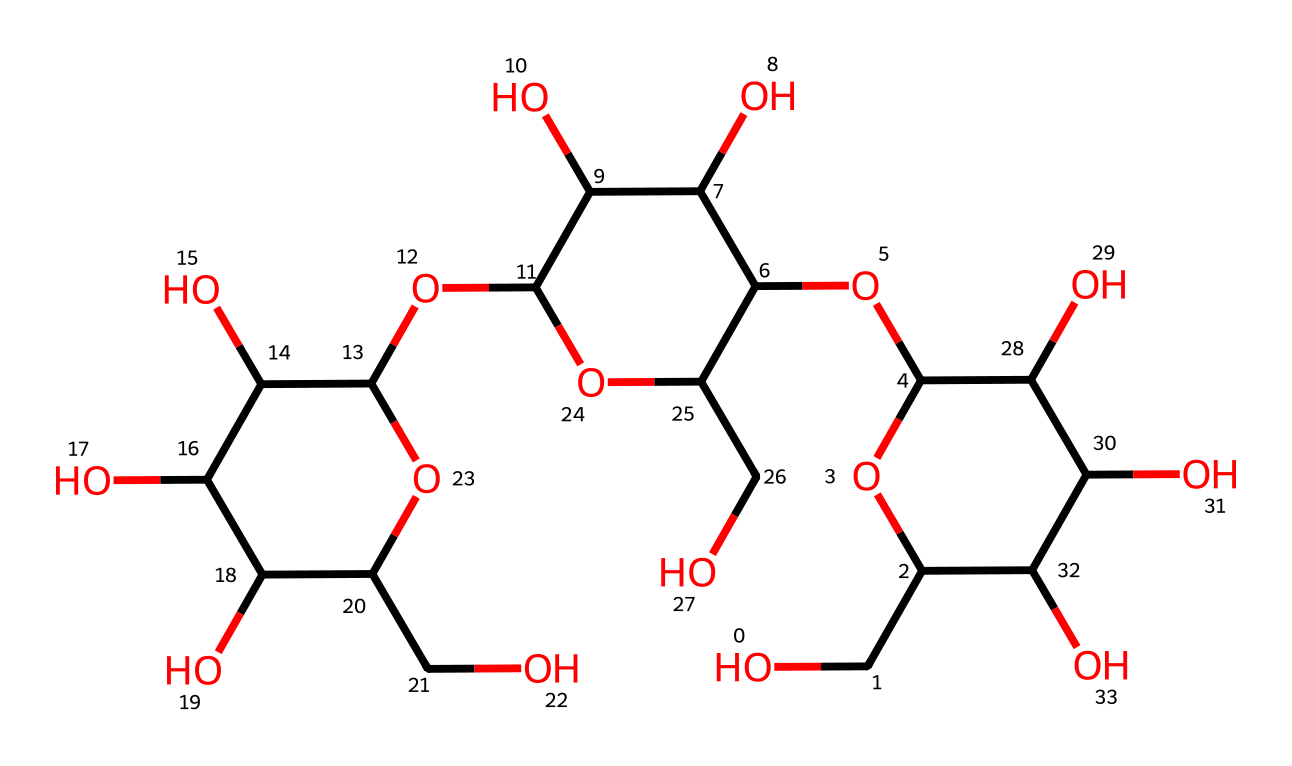What is the molecular formula of this rayon fiber? To determine the molecular formula, we need to count the number of carbon (C), hydrogen (H), and oxygen (O) atoms present in the SMILES representation. By analyzing the structure, we can identify 18 carbon atoms, 34 hydrogen atoms, and 10 oxygen atoms. Therefore, the molecular formula is C18H34O10.
Answer: C18H34O10 How many rings are present in this chemical structure? The SMILES representation illustrates a complex structure with multiple cyclic components. By comparing the depiction in the SMILES notation, we can observe that there are three distinct ring structures within the chemical, indicating three rings are present.
Answer: 3 What functional groups are evident in the structure? By examining the structure, we can identify hydroxyl (OH) groups attached to multiple carbon atoms throughout the molecule. These hydroxy functional groups are responsible for the chemical's interactions and properties, typical in rayon fibers.
Answer: hydroxyl groups Is this rayon fiber biodegradable? Given that rayon is derived from natural cellulose and features hydroxyl groups that can interact with water, it typically has biodegradable properties, allowing it to break down in natural environments.
Answer: yes How many oxygen atoms are involved in ether linkages in this structure? The elongation of rayon fibers involves ether linkages created by the dehydration of hydroxyl groups, which can be counted in the SMILES representation. A careful count shows there are four ether linkages indicated by the connections between carbon atoms through oxygen atoms.
Answer: 4 What is the predominant source material for this type of fiber? Rayon fibers are primarily synthesized from regenerated cellulose, which is derived from natural sources like wood pulp. Since this structure is a derivative of cellulose, it confirms that wood pulp is the predominant source material for rayon fibers.
Answer: wood pulp 